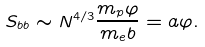Convert formula to latex. <formula><loc_0><loc_0><loc_500><loc_500>S _ { b b } \sim N ^ { 4 / 3 } \frac { m _ { p } \varphi } { m _ { e } b } = a \varphi .</formula> 